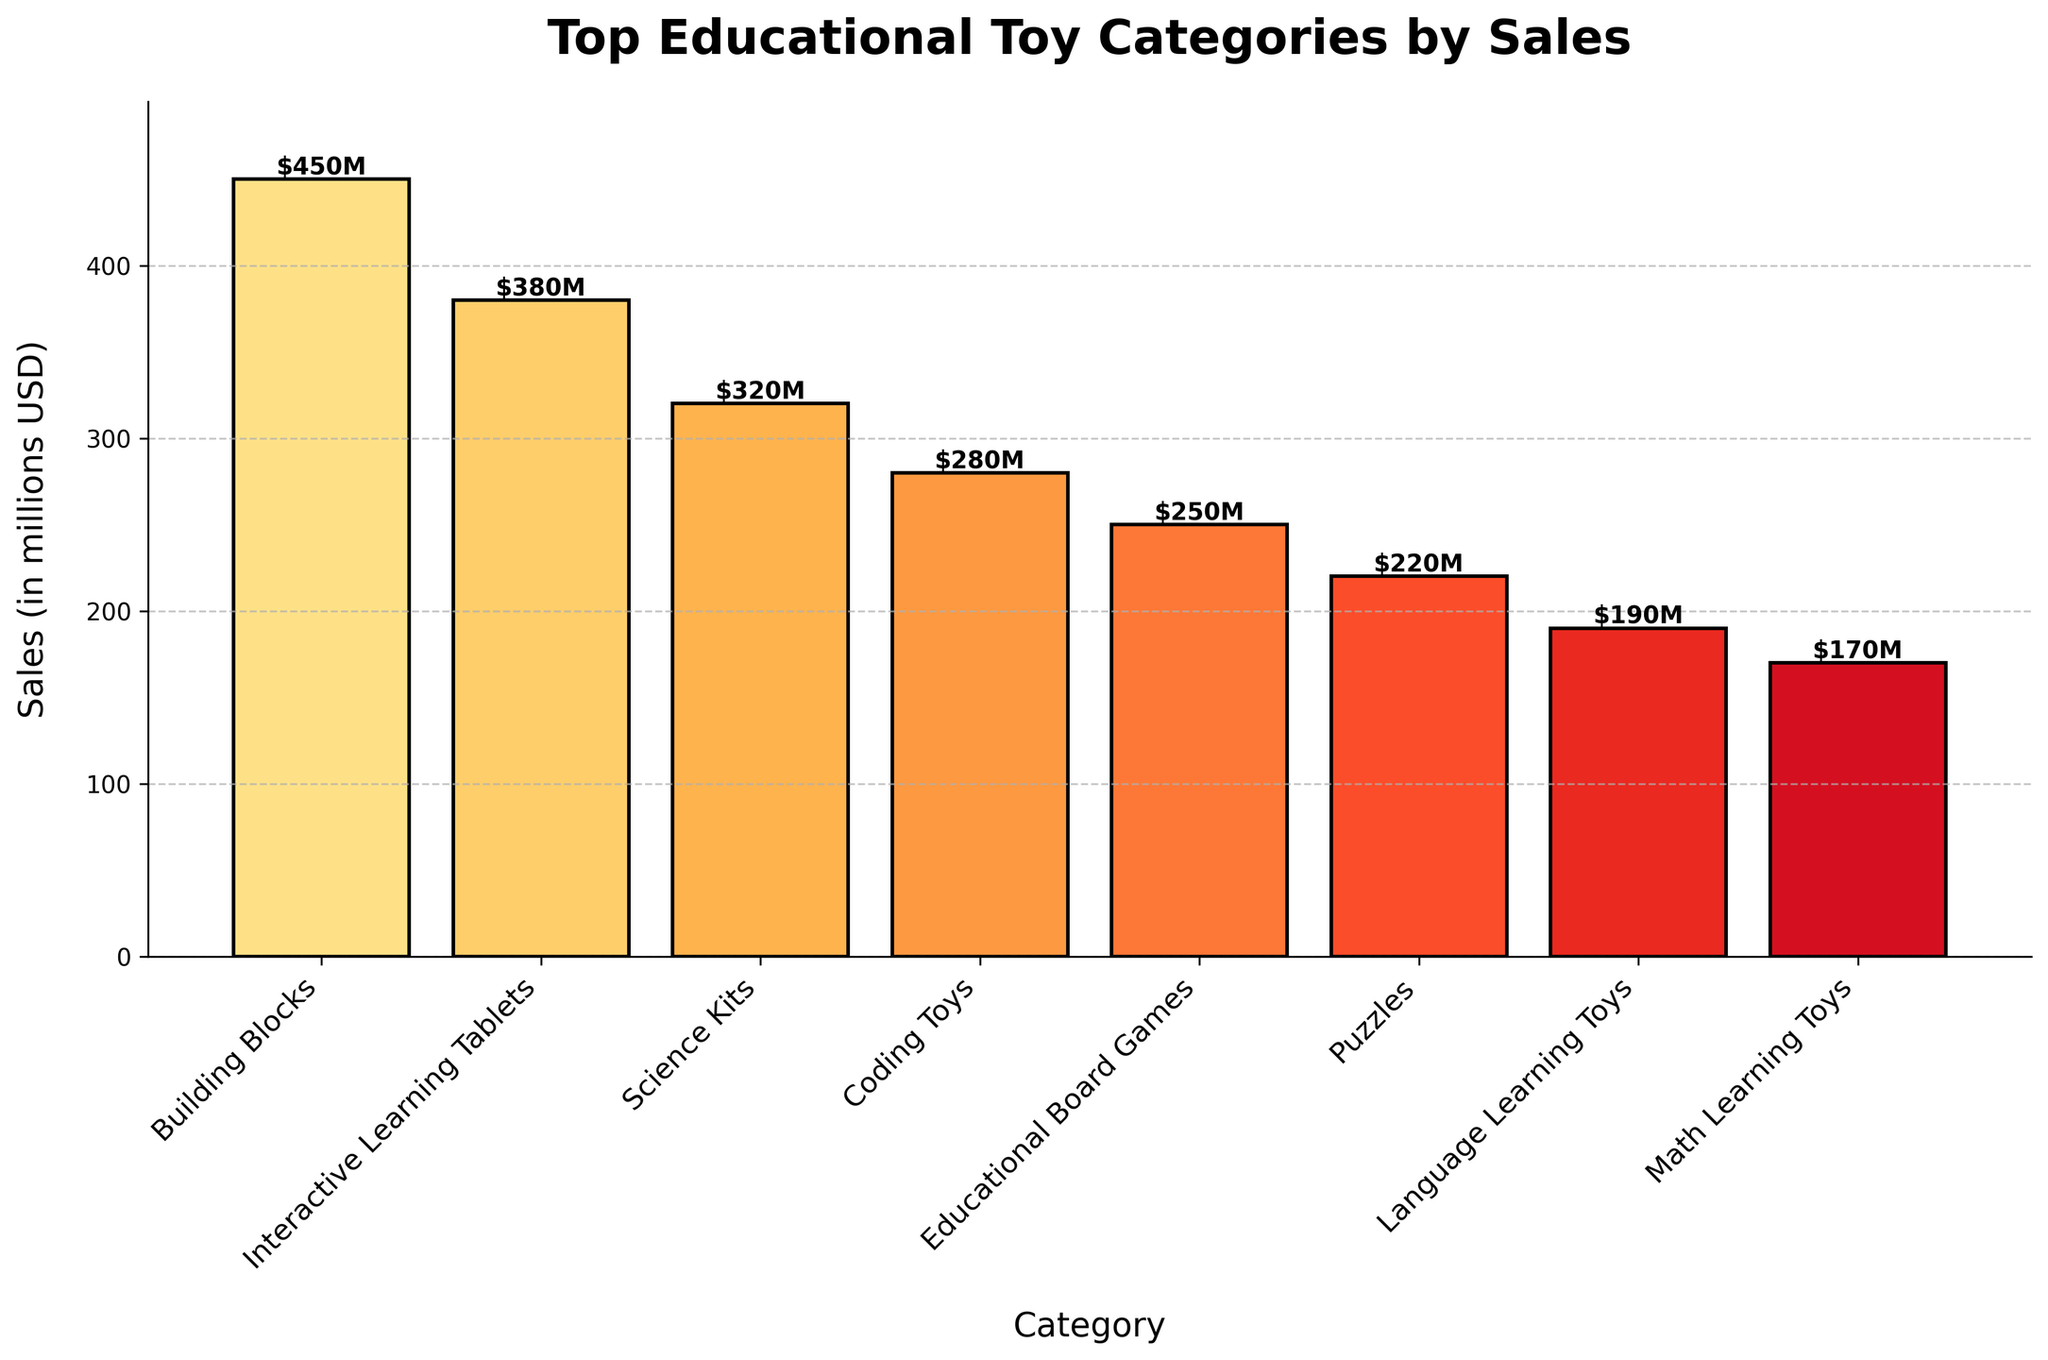What is the top-selling educational toy category? The bar representing "Building Blocks" is the highest with a value of $450M in sales, making it the top-selling category.
Answer: Building Blocks Which category has the least sales among the top 5? Among the top 5 categories shown, "Educational Board Games" has the smallest bar, indicating the least sales of $250M.
Answer: Educational Board Games How much more in sales do Building Blocks have compared to Coding Toys? Sales for Building Blocks are $450M, while for Coding Toys, it's $280M. Subtract $280M from $450M to get the difference. 450 - 280 = 170.
Answer: $170M By how much do Interactive Learning Tablets outsell Science Kits? Sales for Interactive Learning Tablets are $380M, and for Science Kits, it's $320M. Subtract $320M from $380M to get the difference. 380 - 320 = 60.
Answer: $60M What is the total sales of the top 3 categories? Summing up sales for the top 3 categories: Building Blocks ($450M), Interactive Learning Tablets ($380M), and Science Kits ($320M). 450 + 380 + 320 = 1,150.
Answer: $1,150M How does the height of the bar for Science Kits compare to that for Education Board Games? The height of the bar representing Science Kits is greater than that of Educational Board Games, indicating higher sales. The sales are $320M for Science Kits versus $250M for Educational Board Games.
Answer: Science Kits are higher Are there any categories with sales between $300M and $400M? Both "Interactive Learning Tablets" and "Science Kits" fall within this range with $380M and $320M in sales, respectively.
Answer: Yes, two What’s the average sales value of the top 5 categories? Sum the sales of the top 5 categories, which are $450M + $380M + $320M + $280M + $250M = $1,680M, and divide by 5. 1,680 / 5 = 336.
Answer: $336M Out of the top 5, which two categories have the smallest difference in sales? The smallest difference is between "Science Kits" ($320M) and "Coding Toys" ($280M). Subtract 280 from 320 to get the difference: 320 - 280 = 40.
Answer: Science Kits and Coding Toys What is the combined sales of Coding Toys and Educational Board Games? Sum the sales of "Coding Toys" ($280M) and "Educational Board Games" ($250M). 280 +250 = 530.
Answer: $530M 